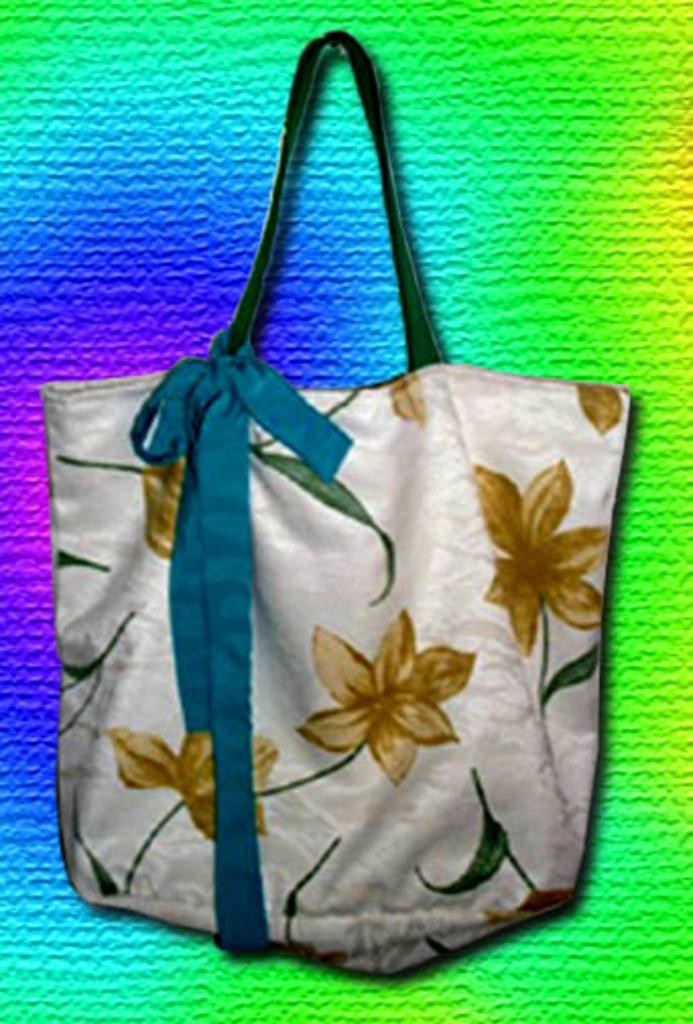What object is present in the image? There is a handbag in the image. How would you describe the background of the image? The background of the image is colorful. What type of mine is depicted in the image? There is no mine present in the image; it features a handbag and a colorful background. 